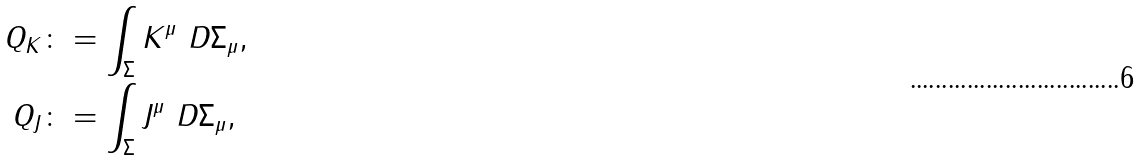<formula> <loc_0><loc_0><loc_500><loc_500>Q _ { K } & \colon = \int _ { \Sigma } K ^ { \mu } \ D \Sigma _ { \mu } , \\ Q _ { J } & \colon = \int _ { \Sigma } J ^ { \mu } \ D \Sigma _ { \mu } ,</formula> 